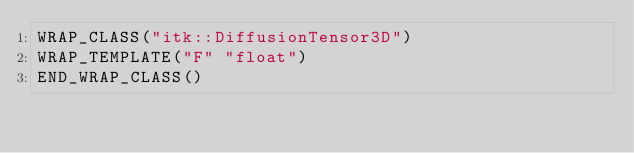<code> <loc_0><loc_0><loc_500><loc_500><_CMake_>WRAP_CLASS("itk::DiffusionTensor3D")
WRAP_TEMPLATE("F" "float")
END_WRAP_CLASS()
</code> 